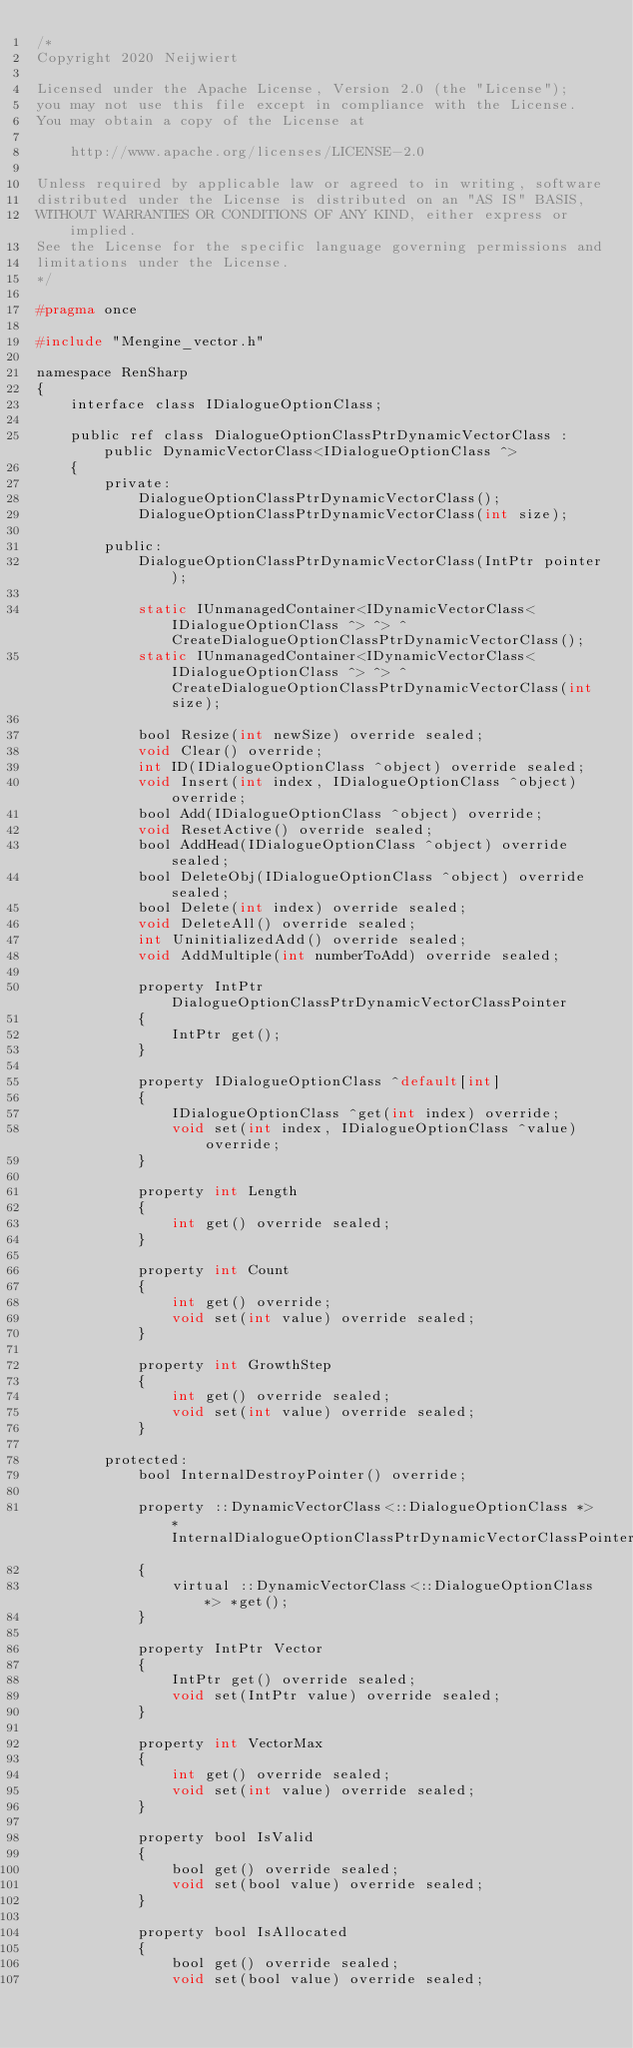<code> <loc_0><loc_0><loc_500><loc_500><_C_>/*
Copyright 2020 Neijwiert

Licensed under the Apache License, Version 2.0 (the "License");
you may not use this file except in compliance with the License.
You may obtain a copy of the License at

    http://www.apache.org/licenses/LICENSE-2.0

Unless required by applicable law or agreed to in writing, software
distributed under the License is distributed on an "AS IS" BASIS,
WITHOUT WARRANTIES OR CONDITIONS OF ANY KIND, either express or implied.
See the License for the specific language governing permissions and
limitations under the License.
*/

#pragma once

#include "Mengine_vector.h"

namespace RenSharp
{
	interface class IDialogueOptionClass;

	public ref class DialogueOptionClassPtrDynamicVectorClass : public DynamicVectorClass<IDialogueOptionClass ^>
	{
		private:
			DialogueOptionClassPtrDynamicVectorClass();
			DialogueOptionClassPtrDynamicVectorClass(int size);

		public:
			DialogueOptionClassPtrDynamicVectorClass(IntPtr pointer);

			static IUnmanagedContainer<IDynamicVectorClass<IDialogueOptionClass ^> ^> ^CreateDialogueOptionClassPtrDynamicVectorClass();
			static IUnmanagedContainer<IDynamicVectorClass<IDialogueOptionClass ^> ^> ^CreateDialogueOptionClassPtrDynamicVectorClass(int size);

			bool Resize(int newSize) override sealed;
			void Clear() override;
			int ID(IDialogueOptionClass ^object) override sealed;
			void Insert(int index, IDialogueOptionClass ^object) override;
			bool Add(IDialogueOptionClass ^object) override;
			void ResetActive() override sealed;
			bool AddHead(IDialogueOptionClass ^object) override sealed;
			bool DeleteObj(IDialogueOptionClass ^object) override sealed;
			bool Delete(int index) override sealed;
			void DeleteAll() override sealed;
			int UninitializedAdd() override sealed;
			void AddMultiple(int numberToAdd) override sealed;

			property IntPtr DialogueOptionClassPtrDynamicVectorClassPointer
			{
				IntPtr get();
			}

			property IDialogueOptionClass ^default[int]
			{
				IDialogueOptionClass ^get(int index) override;
				void set(int index, IDialogueOptionClass ^value) override;
			}

			property int Length
			{
				int get() override sealed;
			}

			property int Count
			{
				int get() override;
				void set(int value) override sealed;
			}

			property int GrowthStep
			{
				int get() override sealed;
				void set(int value) override sealed;
			}

		protected:
			bool InternalDestroyPointer() override;

			property ::DynamicVectorClass<::DialogueOptionClass *> *InternalDialogueOptionClassPtrDynamicVectorClassPointer
			{
				virtual ::DynamicVectorClass<::DialogueOptionClass *> *get();
			}

			property IntPtr Vector
			{
				IntPtr get() override sealed;
				void set(IntPtr value) override sealed;
			}

			property int VectorMax
			{
				int get() override sealed;
				void set(int value) override sealed;
			}

			property bool IsValid
			{
				bool get() override sealed;
				void set(bool value) override sealed;
			}

			property bool IsAllocated
			{
				bool get() override sealed;
				void set(bool value) override sealed;</code> 